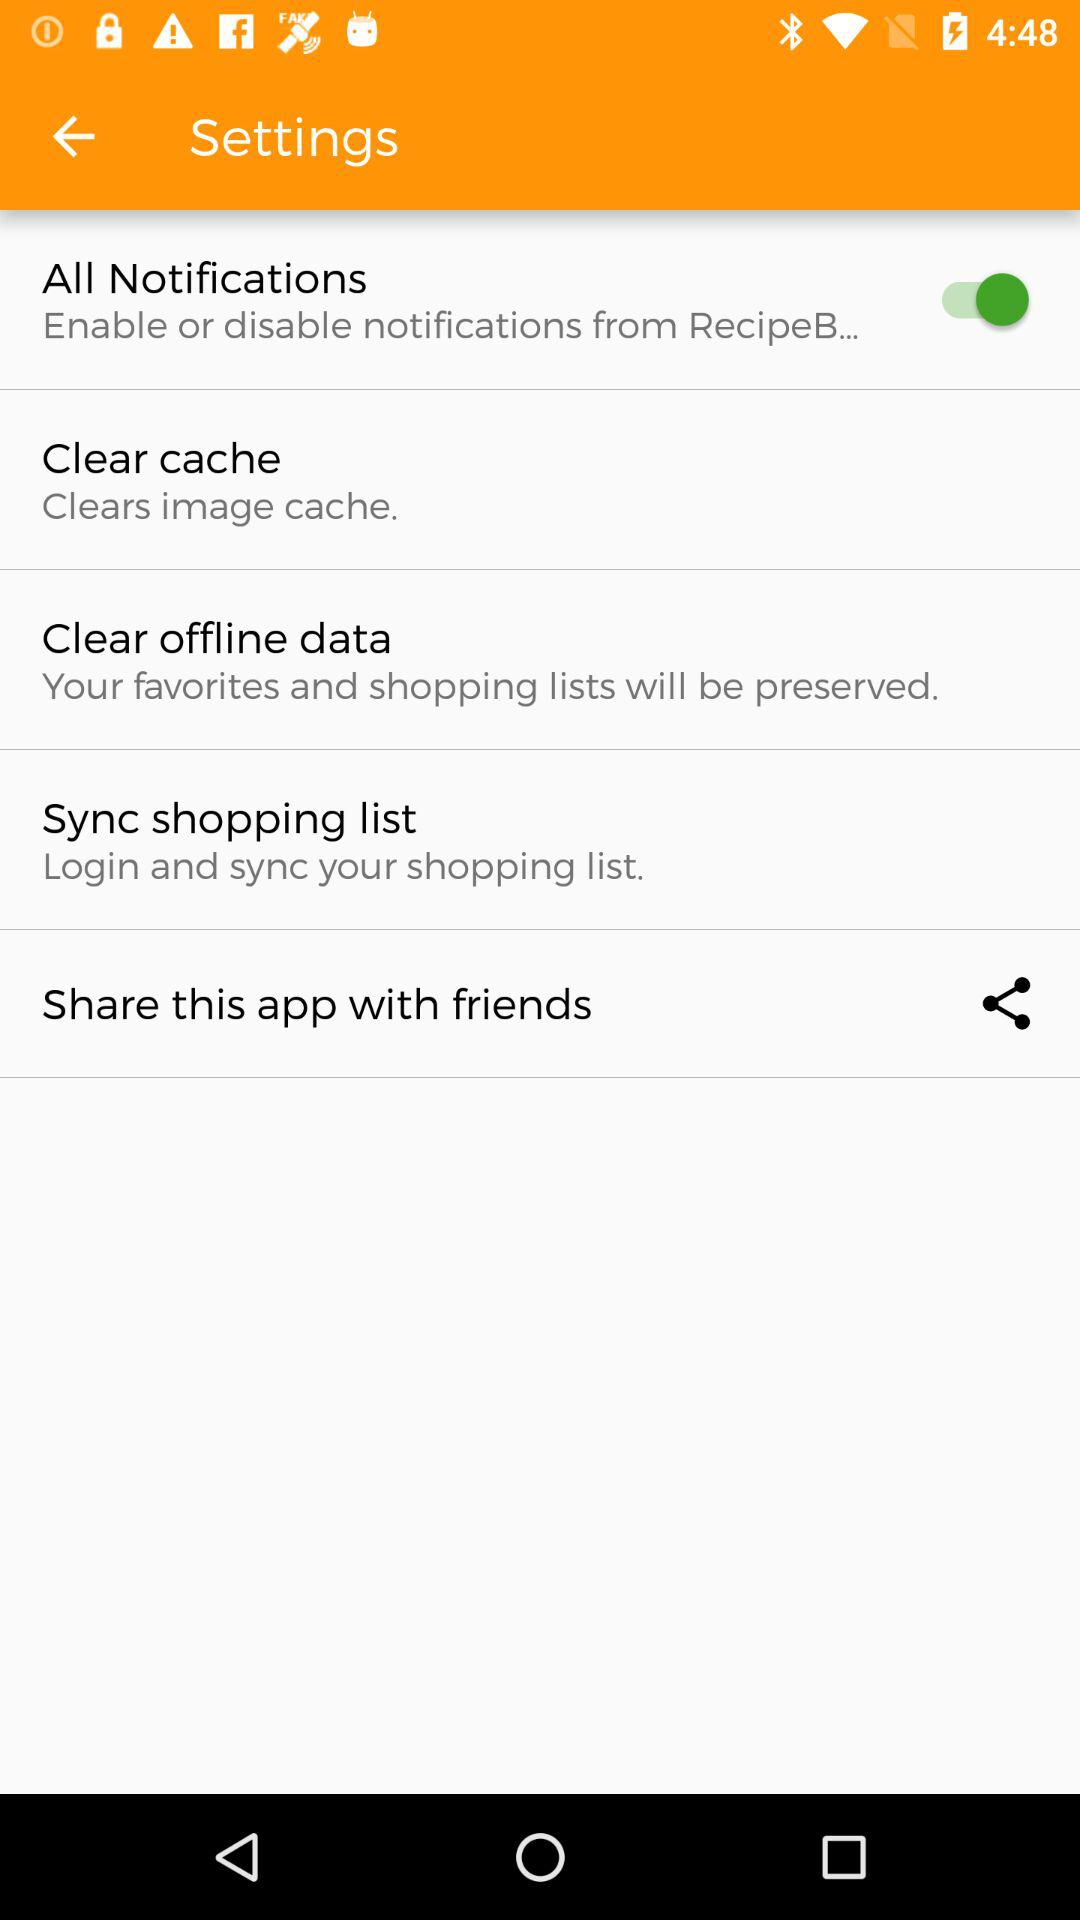What is the status of "All Notifications" settings? The status is "on". 